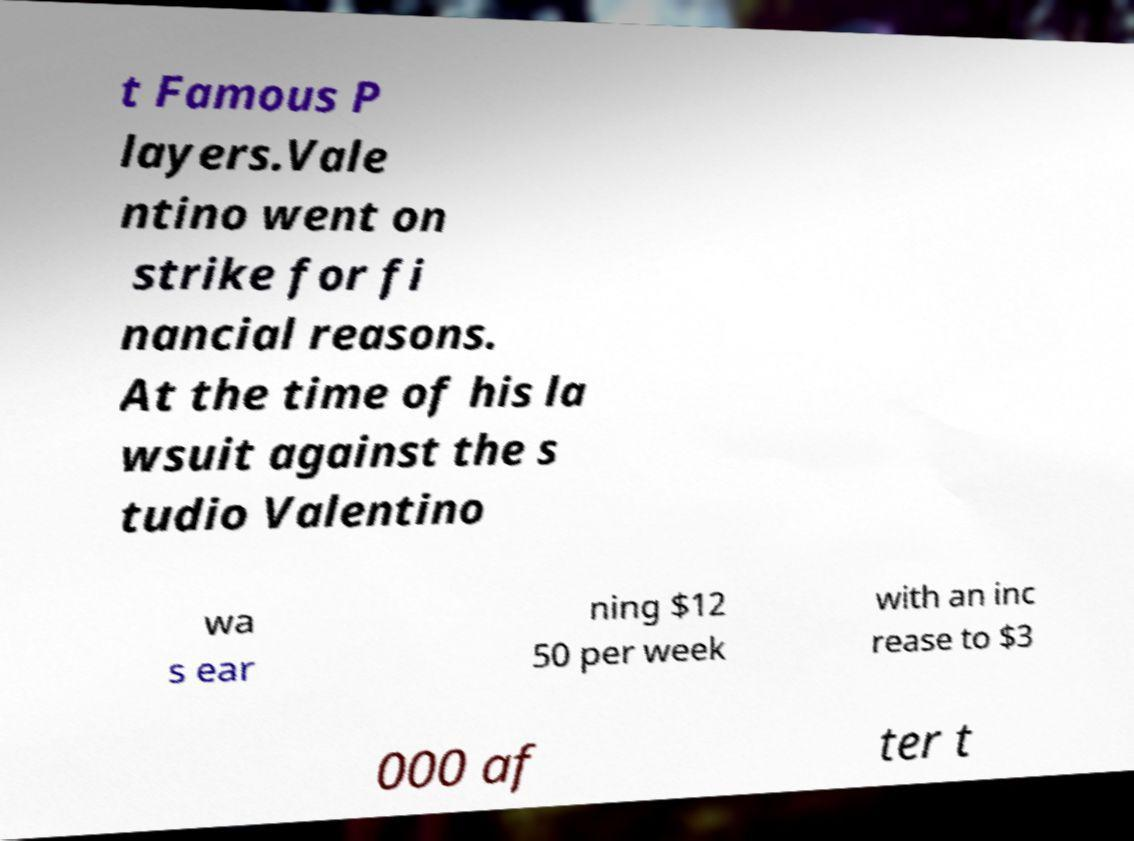There's text embedded in this image that I need extracted. Can you transcribe it verbatim? t Famous P layers.Vale ntino went on strike for fi nancial reasons. At the time of his la wsuit against the s tudio Valentino wa s ear ning $12 50 per week with an inc rease to $3 000 af ter t 